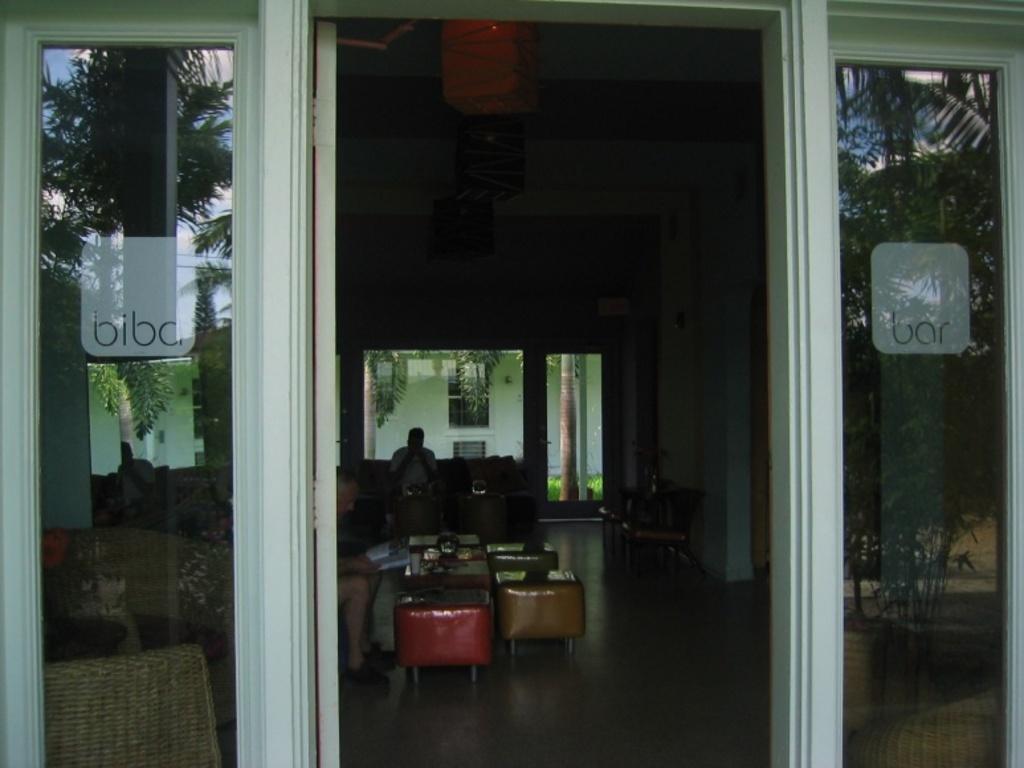Can you describe this image briefly? In the center we can see two persons were sitting on the couch around the table. On table,we can see few objects. And on the left there is a glass. And coming to background we can see trees,building,wall,chairs etc. 